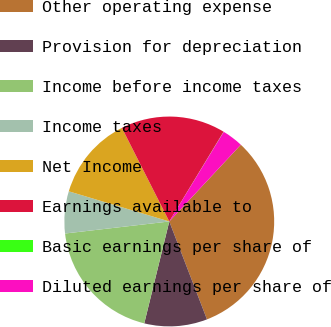Convert chart to OTSL. <chart><loc_0><loc_0><loc_500><loc_500><pie_chart><fcel>Other operating expense<fcel>Provision for depreciation<fcel>Income before income taxes<fcel>Income taxes<fcel>Net Income<fcel>Earnings available to<fcel>Basic earnings per share of<fcel>Diluted earnings per share of<nl><fcel>32.21%<fcel>9.68%<fcel>19.34%<fcel>6.47%<fcel>12.9%<fcel>16.12%<fcel>0.03%<fcel>3.25%<nl></chart> 